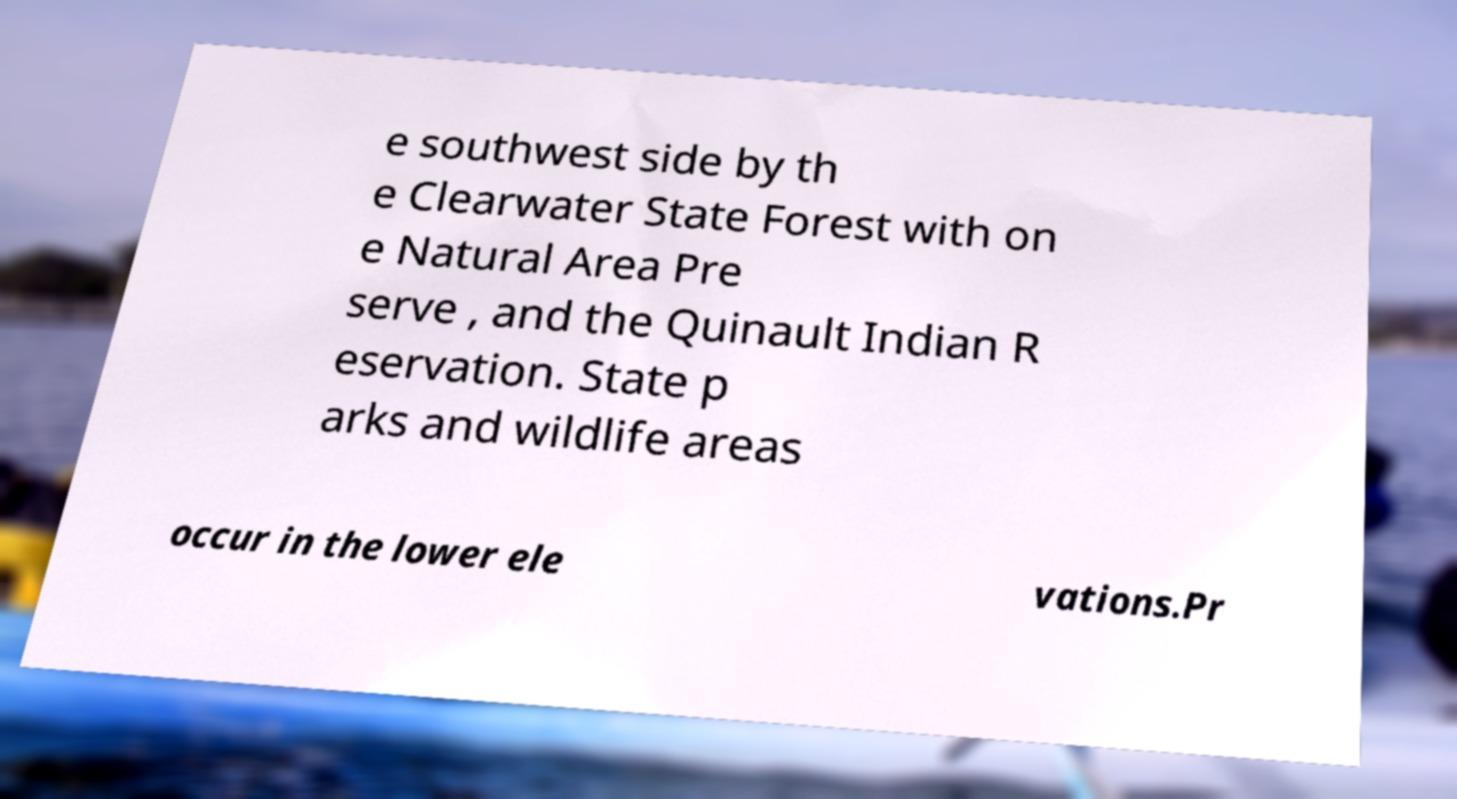Could you assist in decoding the text presented in this image and type it out clearly? e southwest side by th e Clearwater State Forest with on e Natural Area Pre serve , and the Quinault Indian R eservation. State p arks and wildlife areas occur in the lower ele vations.Pr 